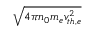Convert formula to latex. <formula><loc_0><loc_0><loc_500><loc_500>\sqrt { 4 \pi n _ { 0 } m _ { e } v _ { t h , e } ^ { 2 } }</formula> 